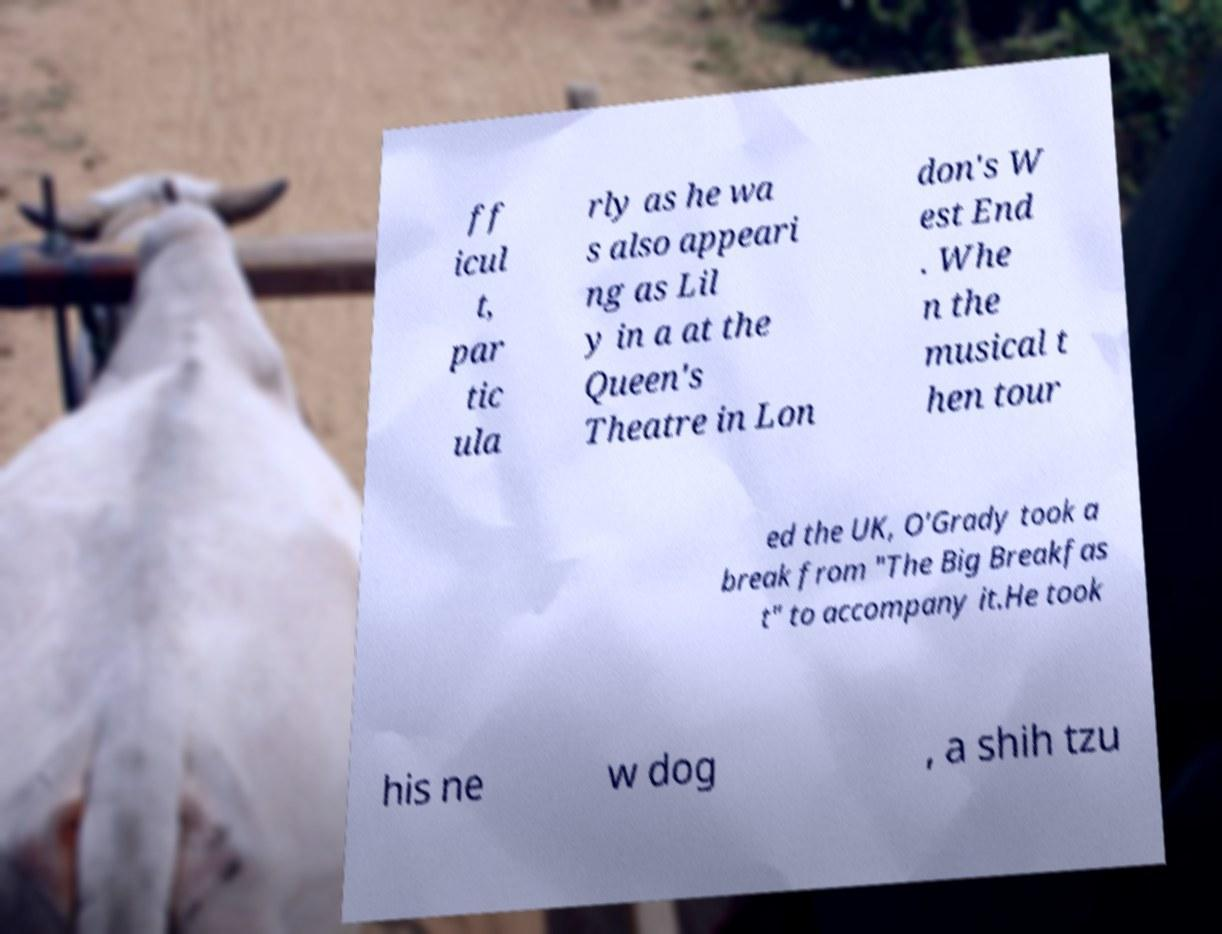Can you accurately transcribe the text from the provided image for me? ff icul t, par tic ula rly as he wa s also appeari ng as Lil y in a at the Queen's Theatre in Lon don's W est End . Whe n the musical t hen tour ed the UK, O'Grady took a break from "The Big Breakfas t" to accompany it.He took his ne w dog , a shih tzu 